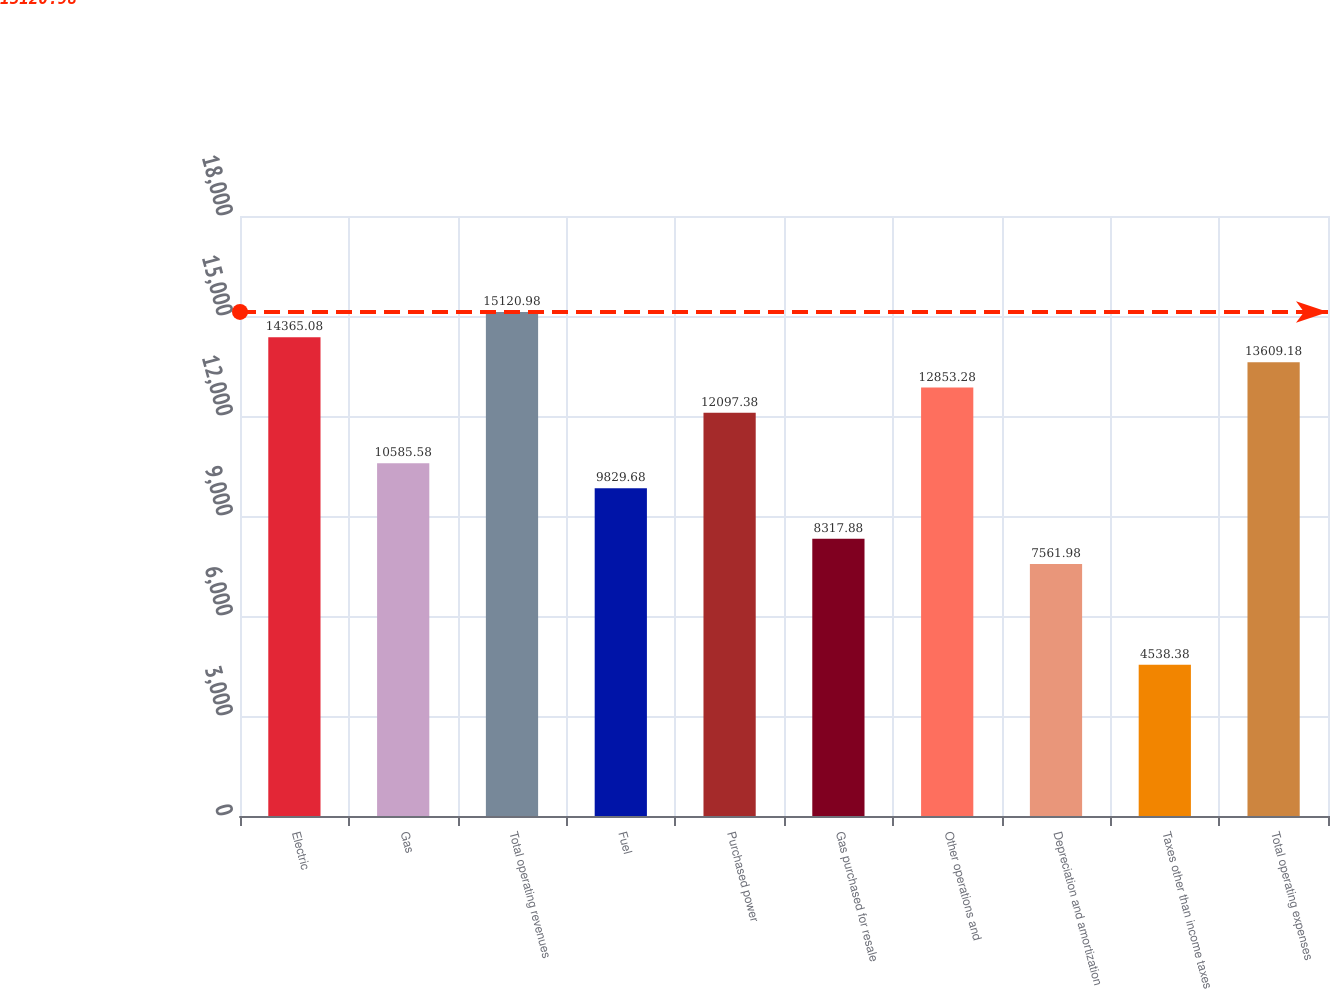Convert chart. <chart><loc_0><loc_0><loc_500><loc_500><bar_chart><fcel>Electric<fcel>Gas<fcel>Total operating revenues<fcel>Fuel<fcel>Purchased power<fcel>Gas purchased for resale<fcel>Other operations and<fcel>Depreciation and amortization<fcel>Taxes other than income taxes<fcel>Total operating expenses<nl><fcel>14365.1<fcel>10585.6<fcel>15121<fcel>9829.68<fcel>12097.4<fcel>8317.88<fcel>12853.3<fcel>7561.98<fcel>4538.38<fcel>13609.2<nl></chart> 